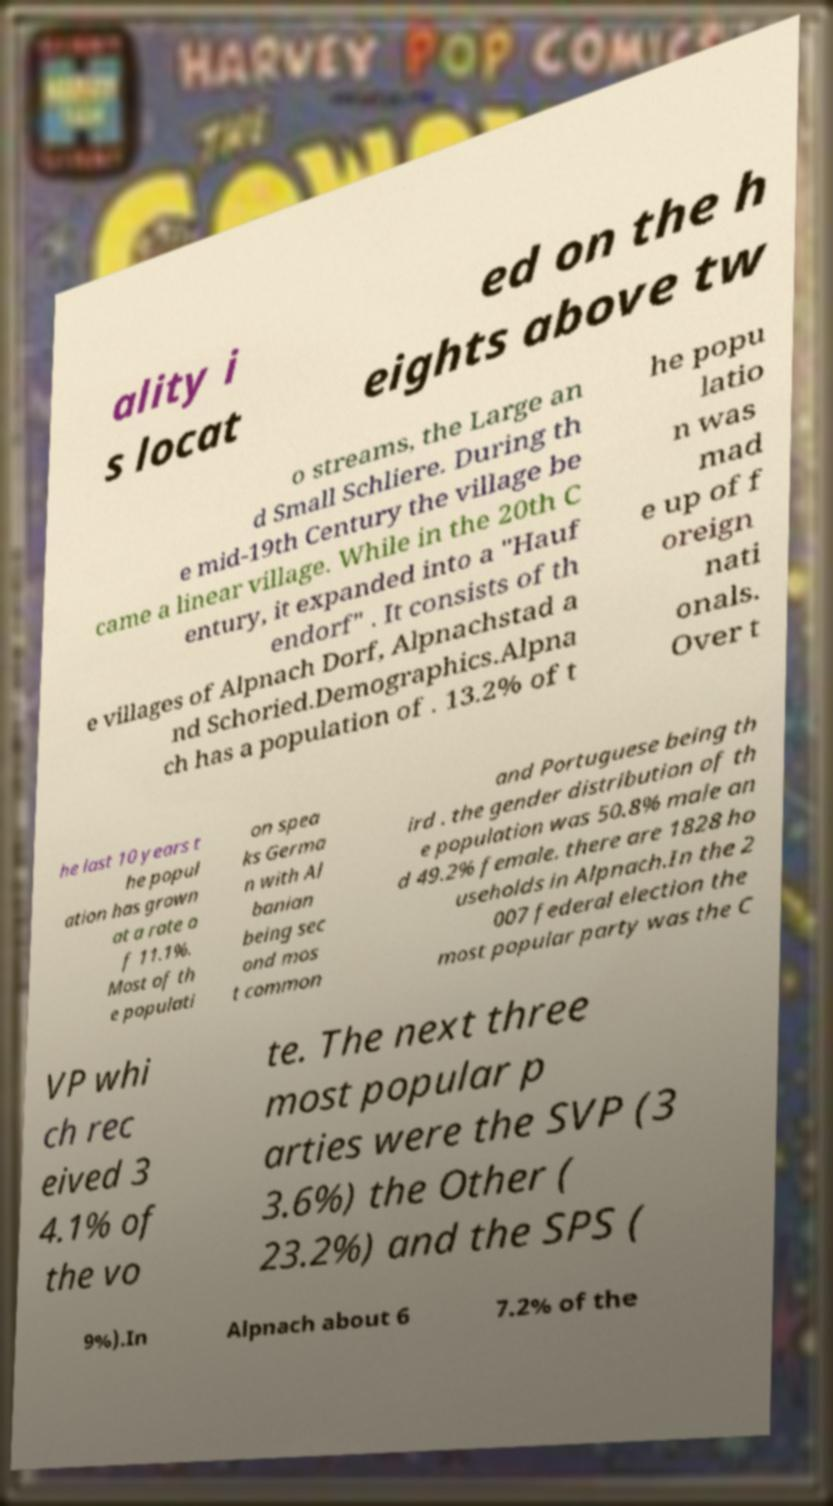Could you assist in decoding the text presented in this image and type it out clearly? ality i s locat ed on the h eights above tw o streams, the Large an d Small Schliere. During th e mid-19th Century the village be came a linear village. While in the 20th C entury, it expanded into a "Hauf endorf" . It consists of th e villages of Alpnach Dorf, Alpnachstad a nd Schoried.Demographics.Alpna ch has a population of . 13.2% of t he popu latio n was mad e up of f oreign nati onals. Over t he last 10 years t he popul ation has grown at a rate o f 11.1%. Most of th e populati on spea ks Germa n with Al banian being sec ond mos t common and Portuguese being th ird . the gender distribution of th e population was 50.8% male an d 49.2% female. there are 1828 ho useholds in Alpnach.In the 2 007 federal election the most popular party was the C VP whi ch rec eived 3 4.1% of the vo te. The next three most popular p arties were the SVP (3 3.6%) the Other ( 23.2%) and the SPS ( 9%).In Alpnach about 6 7.2% of the 